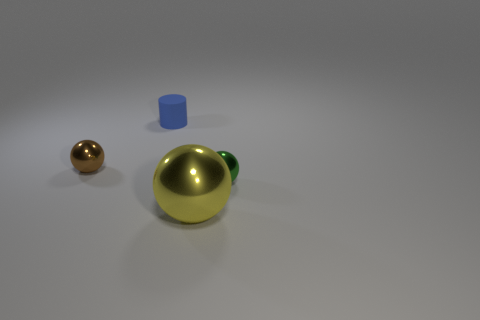Add 2 metallic cylinders. How many objects exist? 6 Subtract all spheres. How many objects are left? 1 Add 3 tiny blue cylinders. How many tiny blue cylinders are left? 4 Add 3 gray metallic spheres. How many gray metallic spheres exist? 3 Subtract 0 red balls. How many objects are left? 4 Subtract all small brown shiny balls. Subtract all green shiny balls. How many objects are left? 2 